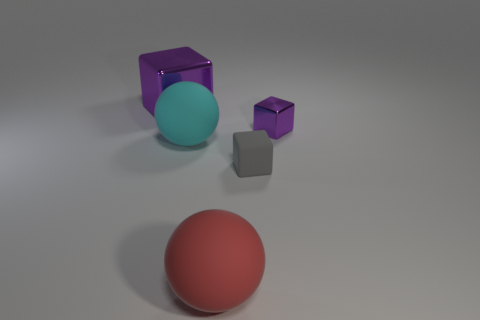What number of things are either big objects that are behind the tiny metallic object or small gray metal things?
Ensure brevity in your answer.  1. There is a purple block that is behind the small object that is behind the matte sphere on the left side of the large red sphere; what is its material?
Provide a short and direct response. Metal. Are there more purple metallic cubes in front of the small rubber object than large purple metallic objects that are on the left side of the large purple block?
Provide a short and direct response. No. How many cylinders are gray things or cyan objects?
Provide a succinct answer. 0. There is a purple block that is to the right of the object to the left of the cyan object; how many purple things are on the left side of it?
Give a very brief answer. 1. There is a object that is the same color as the small shiny block; what is its material?
Offer a very short reply. Metal. Is the number of big purple blocks greater than the number of small brown metal things?
Provide a succinct answer. Yes. Do the gray object and the cyan sphere have the same size?
Your answer should be compact. No. How many objects are small blue cylinders or gray matte cubes?
Your response must be concise. 1. There is a matte thing behind the tiny gray block in front of the purple metallic thing that is right of the big red thing; what shape is it?
Keep it short and to the point. Sphere. 